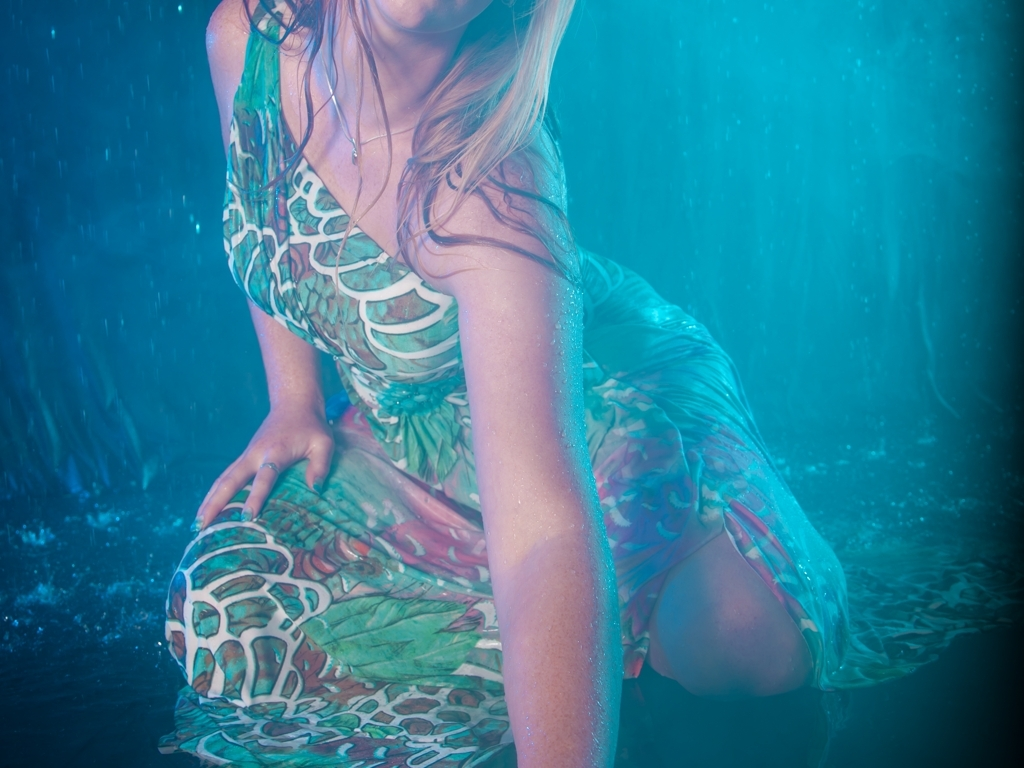What emotions could the subject's posture and setting evoke in a viewer? The subject's posture—couched low and in close contact with the surface—combined with the serene blue environment, may evoke feelings of tranquility, contemplation, and a connection with nature. The intentional use of water elements can also convey a sense of renewal or purity, inviting the viewer to project their own emotions onto the scene. 